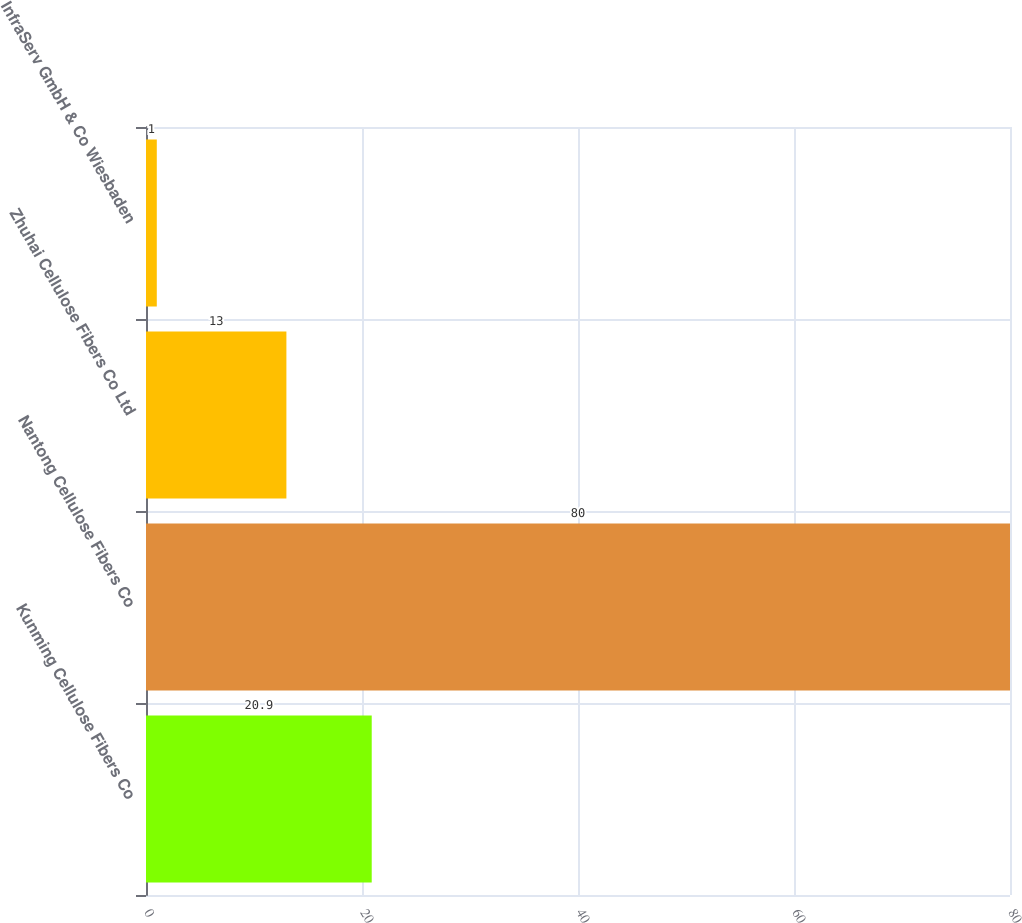Convert chart. <chart><loc_0><loc_0><loc_500><loc_500><bar_chart><fcel>Kunming Cellulose Fibers Co<fcel>Nantong Cellulose Fibers Co<fcel>Zhuhai Cellulose Fibers Co Ltd<fcel>InfraServ GmbH & Co Wiesbaden<nl><fcel>20.9<fcel>80<fcel>13<fcel>1<nl></chart> 